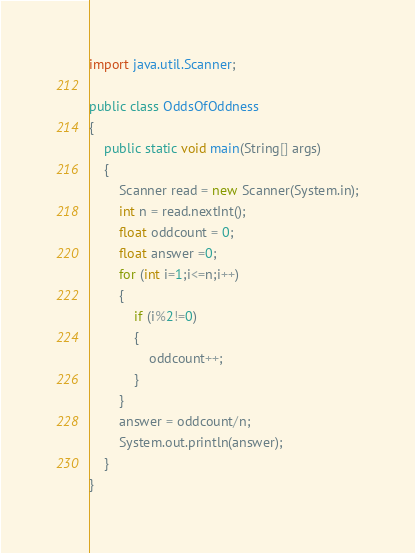<code> <loc_0><loc_0><loc_500><loc_500><_Java_>import java.util.Scanner;

public class OddsOfOddness
{
    public static void main(String[] args)
    {
        Scanner read = new Scanner(System.in);
        int n = read.nextInt();
        float oddcount = 0;
        float answer =0;
        for (int i=1;i<=n;i++)
        {
            if (i%2!=0)
            {
                oddcount++;
            }
        }
        answer = oddcount/n;
        System.out.println(answer);
    }
}
</code> 